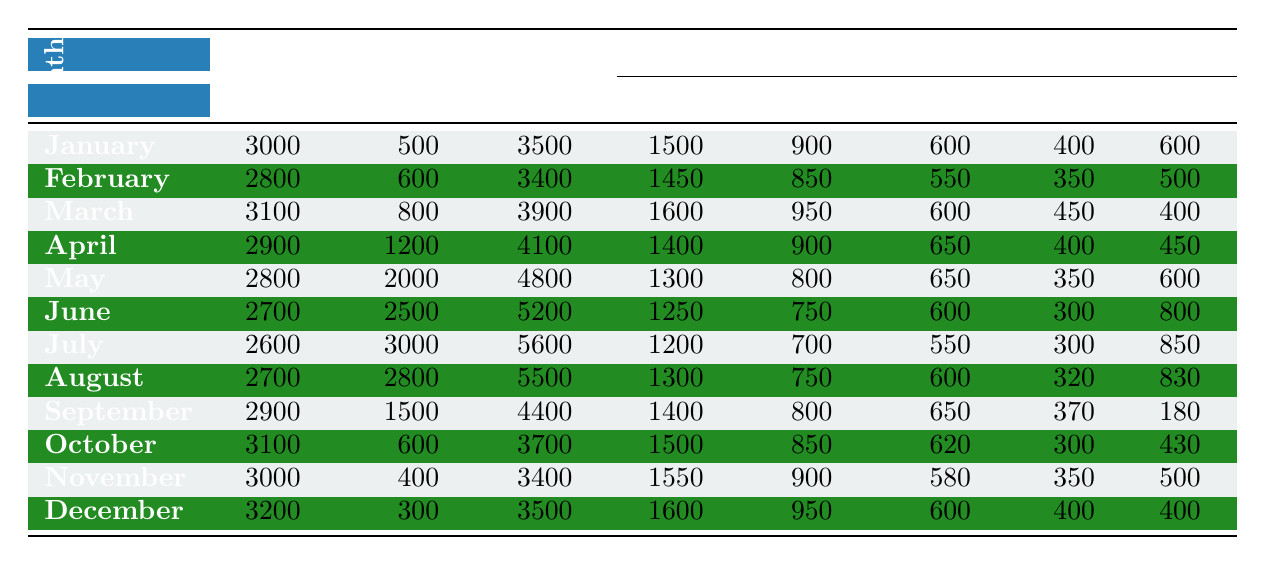What was the total water usage in July? In July, the Total Usage Gallons is listed as 5600.
Answer: 5600 How much water was used for dishwashing in February? In February, the Major Usage Activities shows Dishwashing as 350 gallons.
Answer: 350 Which month had the highest total water usage? By comparing the Total Usage Gallons for each month, June has the highest total at 5200 gallons.
Answer: June What is the difference in indoor water usage between January and December? Indoor usage in January is 3000 gallons and in December it is 3200 gallons. The difference is 3200 - 3000 = 200 gallons.
Answer: 200 What was the average outdoor water usage for the first half of the year (January to June)? Add the outdoor water usage for January (500), February (600), March (800), April (1200), May (2000), and June (2500) to get 500 + 600 + 800 + 1200 + 2000 + 2500 = 6600 gallons. Dividing by 6 months gives an average of 6600/6 = 1100 gallons.
Answer: 1100 Did the outdoor water usage increase in July compared to June? The outdoor usage in July is 3000 gallons, and in June, it is 2500 gallons. Since 3000 is greater than 2500, the outdoor usage increased.
Answer: Yes What was the total water usage for the last quarter of the year (October to December)? The total water usage for October is 3700, November is 3400, and December is 3500. Summing these gives 3700 + 3400 + 3500 = 10600 gallons for the last quarter.
Answer: 10600 Which month had the lowest indoor water usage? The lowest indoor usage is in July with 2600 gallons, based on a review of all the indoor values.
Answer: July Is the total water usage in April greater than the total in September? In April, the total usage is 4100 gallons and in September, it is 4400 gallons. Since 4100 is less than 4400, April's total is not greater.
Answer: No What is the trend of indoor water usage from January to July? Analyzing the indoor usage values: January (3000), February (2800), March (3100), April (2900), May (2800), June (2700), and July (2600) shows a decline after March, indicating a downward trend.
Answer: Downward What percentage of the total water usage in June was for showers? Showers in June used 1250 gallons, and total usage was 5200 gallons. The percentage is (1250 / 5200) * 100 = 24.04%.
Answer: 24.04% 